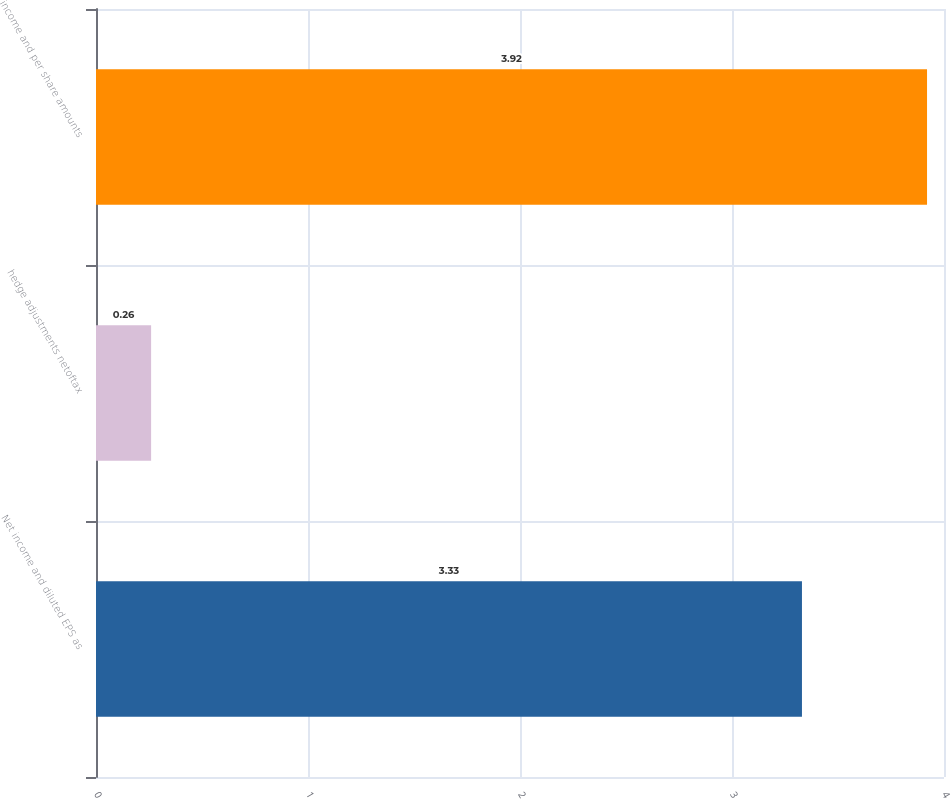Convert chart to OTSL. <chart><loc_0><loc_0><loc_500><loc_500><bar_chart><fcel>Net income and diluted EPS as<fcel>hedge adjustments netoftax<fcel>income and per share amounts<nl><fcel>3.33<fcel>0.26<fcel>3.92<nl></chart> 